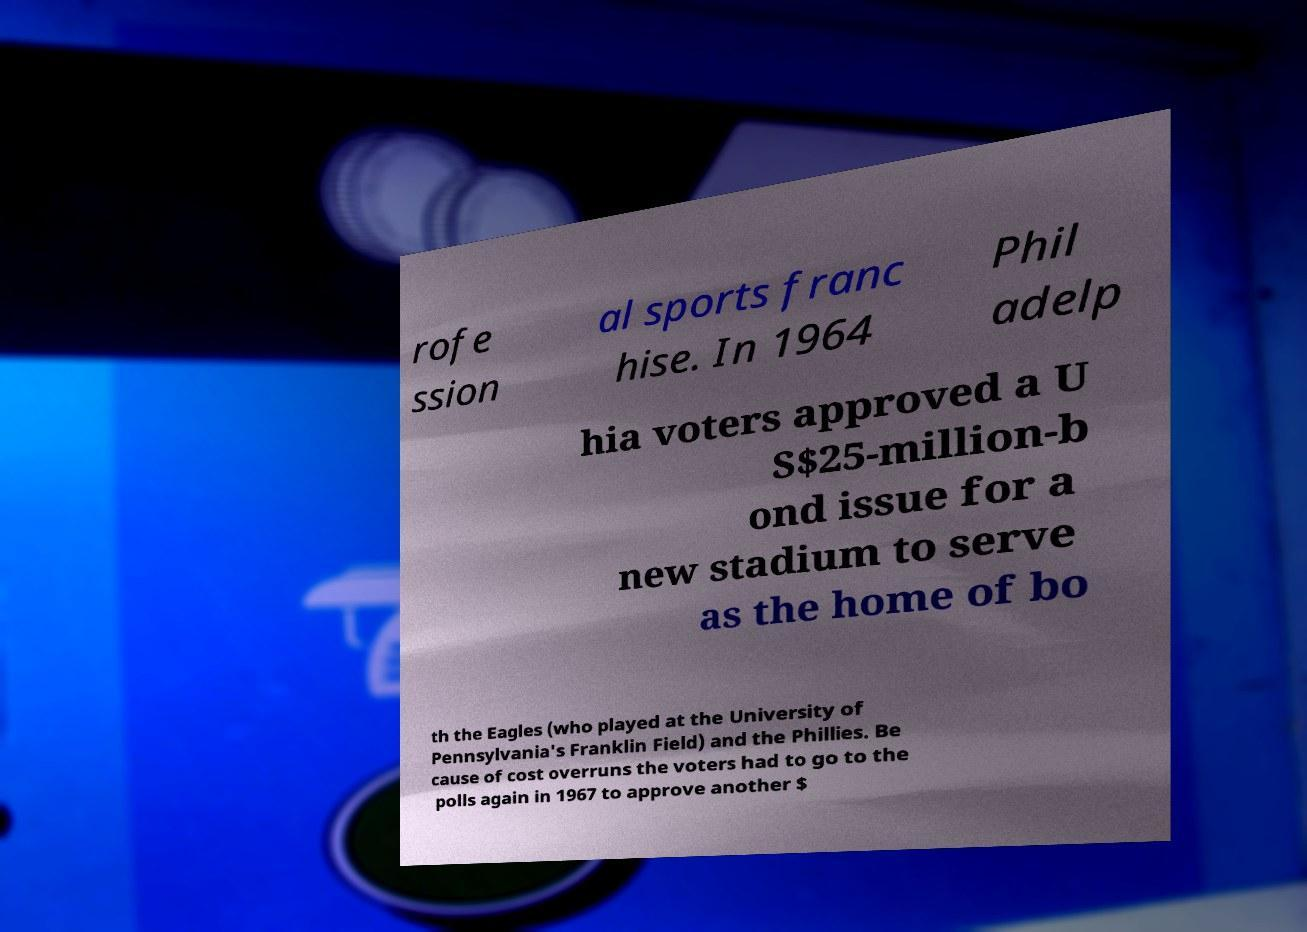Please identify and transcribe the text found in this image. rofe ssion al sports franc hise. In 1964 Phil adelp hia voters approved a U S$25-million-b ond issue for a new stadium to serve as the home of bo th the Eagles (who played at the University of Pennsylvania's Franklin Field) and the Phillies. Be cause of cost overruns the voters had to go to the polls again in 1967 to approve another $ 